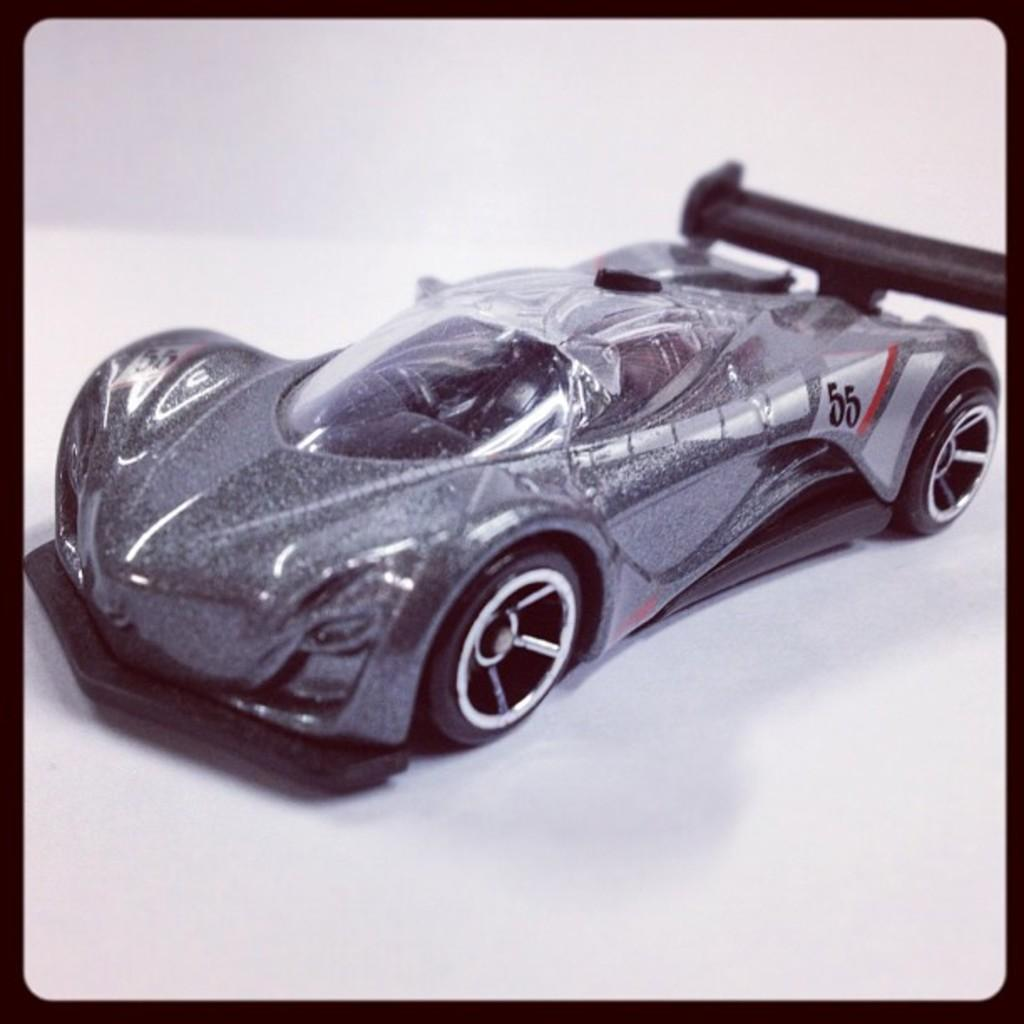<image>
Provide a brief description of the given image. A black car has the number 55 on the side. 